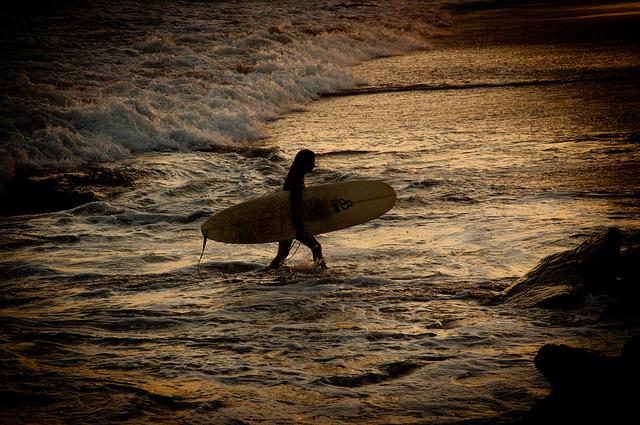What is he walking on?
Keep it brief. Beach. Is the person in the water?
Short answer required. Yes. Is it evening or day?
Write a very short answer. Evening. What gender is the person in the photo?
Short answer required. Female. What is this person holding?
Give a very brief answer. Surfboard. 